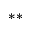<formula> <loc_0><loc_0><loc_500><loc_500>^ { * * }</formula> 